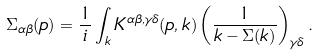Convert formula to latex. <formula><loc_0><loc_0><loc_500><loc_500>\Sigma _ { \alpha \beta } ( p ) = \frac { 1 } { i } \int _ { k } K ^ { \alpha \beta , \gamma \delta } ( p , k ) \left ( \frac { 1 } { \sl k - \Sigma ( k ) } \right ) _ { \gamma \delta } .</formula> 